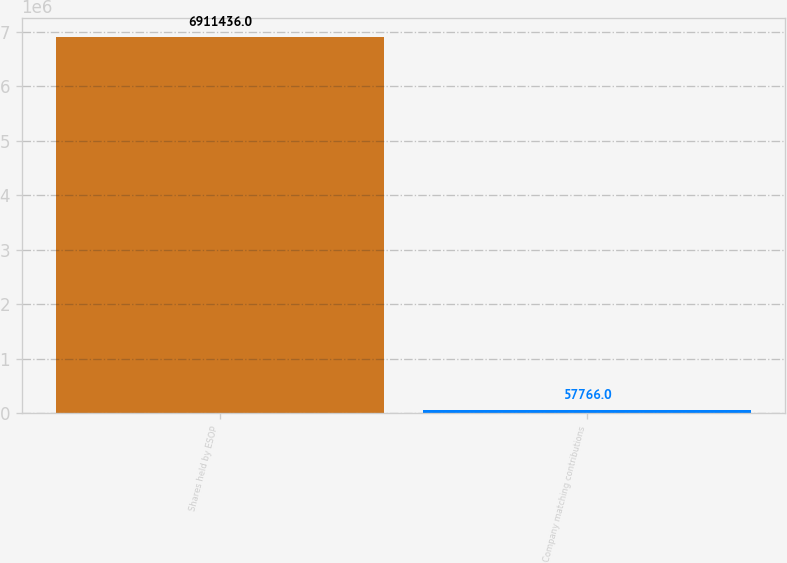Convert chart to OTSL. <chart><loc_0><loc_0><loc_500><loc_500><bar_chart><fcel>Shares held by ESOP<fcel>Company matching contributions<nl><fcel>6.91144e+06<fcel>57766<nl></chart> 